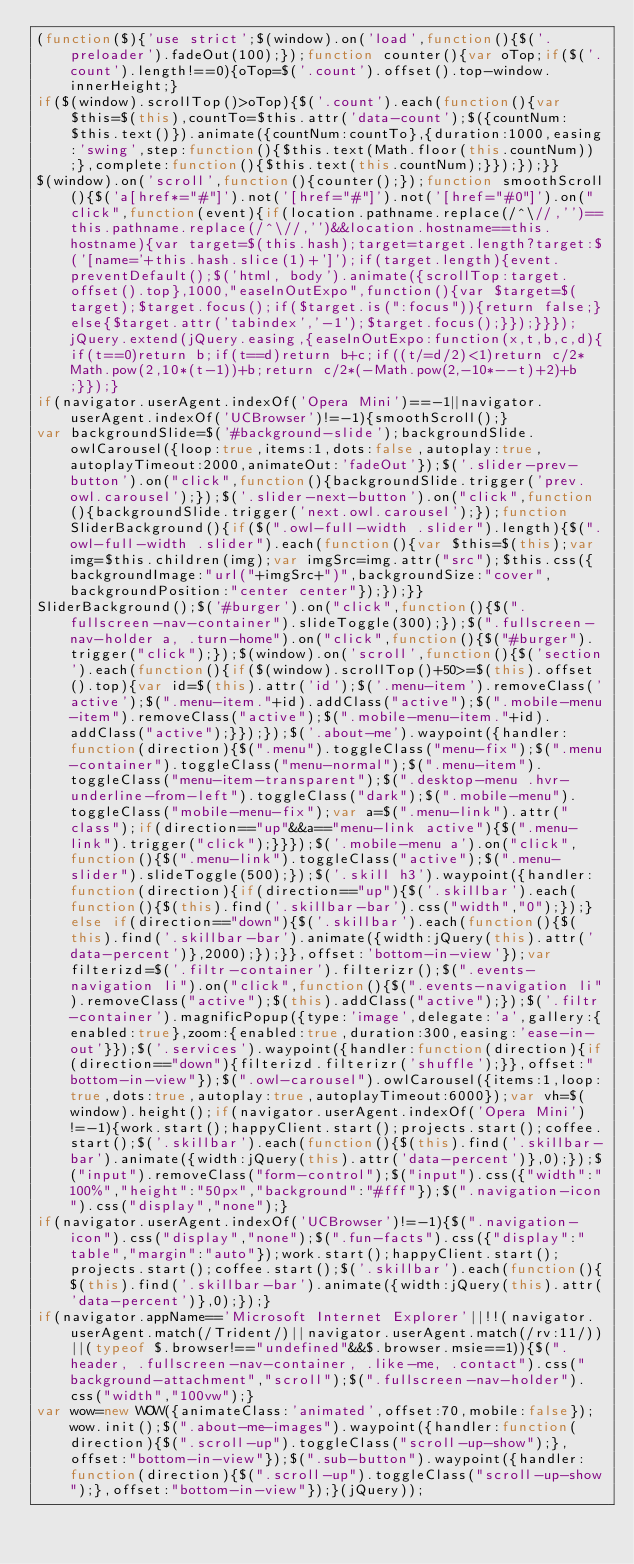Convert code to text. <code><loc_0><loc_0><loc_500><loc_500><_JavaScript_>(function($){'use strict';$(window).on('load',function(){$('.preloader').fadeOut(100);});function counter(){var oTop;if($('.count').length!==0){oTop=$('.count').offset().top-window.innerHeight;}
if($(window).scrollTop()>oTop){$('.count').each(function(){var $this=$(this),countTo=$this.attr('data-count');$({countNum:$this.text()}).animate({countNum:countTo},{duration:1000,easing:'swing',step:function(){$this.text(Math.floor(this.countNum));},complete:function(){$this.text(this.countNum);}});});}}
$(window).on('scroll',function(){counter();});function smoothScroll(){$('a[href*="#"]').not('[href="#"]').not('[href="#0"]').on("click",function(event){if(location.pathname.replace(/^\//,'')==this.pathname.replace(/^\//,'')&&location.hostname==this.hostname){var target=$(this.hash);target=target.length?target:$('[name='+this.hash.slice(1)+']');if(target.length){event.preventDefault();$('html, body').animate({scrollTop:target.offset().top},1000,"easeInOutExpo",function(){var $target=$(target);$target.focus();if($target.is(":focus")){return false;}else{$target.attr('tabindex','-1');$target.focus();}});}}});jQuery.extend(jQuery.easing,{easeInOutExpo:function(x,t,b,c,d){if(t==0)return b;if(t==d)return b+c;if((t/=d/2)<1)return c/2*Math.pow(2,10*(t-1))+b;return c/2*(-Math.pow(2,-10*--t)+2)+b;}});}
if(navigator.userAgent.indexOf('Opera Mini')==-1||navigator.userAgent.indexOf('UCBrowser')!=-1){smoothScroll();}
var backgroundSlide=$('#background-slide');backgroundSlide.owlCarousel({loop:true,items:1,dots:false,autoplay:true,autoplayTimeout:2000,animateOut:'fadeOut'});$('.slider-prev-button').on("click",function(){backgroundSlide.trigger('prev.owl.carousel');});$('.slider-next-button').on("click",function(){backgroundSlide.trigger('next.owl.carousel');});function SliderBackground(){if($(".owl-full-width .slider").length){$(".owl-full-width .slider").each(function(){var $this=$(this);var img=$this.children(img);var imgSrc=img.attr("src");$this.css({backgroundImage:"url("+imgSrc+")",backgroundSize:"cover",backgroundPosition:"center center"});});}}
SliderBackground();$('#burger').on("click",function(){$(".fullscreen-nav-container").slideToggle(300);});$(".fullscreen-nav-holder a, .turn-home").on("click",function(){$("#burger").trigger("click");});$(window).on('scroll',function(){$('section').each(function(){if($(window).scrollTop()+50>=$(this).offset().top){var id=$(this).attr('id');$('.menu-item').removeClass('active');$(".menu-item."+id).addClass("active");$(".mobile-menu-item").removeClass("active");$(".mobile-menu-item."+id).addClass("active");}});});$('.about-me').waypoint({handler:function(direction){$(".menu").toggleClass("menu-fix");$(".menu-container").toggleClass("menu-normal");$(".menu-item").toggleClass("menu-item-transparent");$(".desktop-menu .hvr-underline-from-left").toggleClass("dark");$(".mobile-menu").toggleClass("mobile-menu-fix");var a=$(".menu-link").attr("class");if(direction=="up"&&a=="menu-link active"){$(".menu-link").trigger("click");}}});$('.mobile-menu a').on("click",function(){$(".menu-link").toggleClass("active");$(".menu-slider").slideToggle(500);});$('.skill h3').waypoint({handler:function(direction){if(direction=="up"){$('.skillbar').each(function(){$(this).find('.skillbar-bar').css("width","0");});}else if(direction=="down"){$('.skillbar').each(function(){$(this).find('.skillbar-bar').animate({width:jQuery(this).attr('data-percent')},2000);});}},offset:'bottom-in-view'});var filterizd=$('.filtr-container').filterizr();$(".events-navigation li").on("click",function(){$(".events-navigation li").removeClass("active");$(this).addClass("active");});$('.filtr-container').magnificPopup({type:'image',delegate:'a',gallery:{enabled:true},zoom:{enabled:true,duration:300,easing:'ease-in-out'}});$('.services').waypoint({handler:function(direction){if(direction=="down"){filterizd.filterizr('shuffle');}},offset:"bottom-in-view"});$(".owl-carousel").owlCarousel({items:1,loop:true,dots:true,autoplay:true,autoplayTimeout:6000});var vh=$(window).height();if(navigator.userAgent.indexOf('Opera Mini')!=-1){work.start();happyClient.start();projects.start();coffee.start();$('.skillbar').each(function(){$(this).find('.skillbar-bar').animate({width:jQuery(this).attr('data-percent')},0);});$("input").removeClass("form-control");$("input").css({"width":"100%","height":"50px","background":"#fff"});$(".navigation-icon").css("display","none");}
if(navigator.userAgent.indexOf('UCBrowser')!=-1){$(".navigation-icon").css("display","none");$(".fun-facts").css({"display":"table","margin":"auto"});work.start();happyClient.start();projects.start();coffee.start();$('.skillbar').each(function(){$(this).find('.skillbar-bar').animate({width:jQuery(this).attr('data-percent')},0);});}
if(navigator.appName=='Microsoft Internet Explorer'||!!(navigator.userAgent.match(/Trident/)||navigator.userAgent.match(/rv:11/))||(typeof $.browser!=="undefined"&&$.browser.msie==1)){$(".header, .fullscreen-nav-container, .like-me, .contact").css("background-attachment","scroll");$(".fullscreen-nav-holder").css("width","100vw");}
var wow=new WOW({animateClass:'animated',offset:70,mobile:false});wow.init();$(".about-me-images").waypoint({handler:function(direction){$(".scroll-up").toggleClass("scroll-up-show");},offset:"bottom-in-view"});$(".sub-button").waypoint({handler:function(direction){$(".scroll-up").toggleClass("scroll-up-show");},offset:"bottom-in-view"});}(jQuery));</code> 